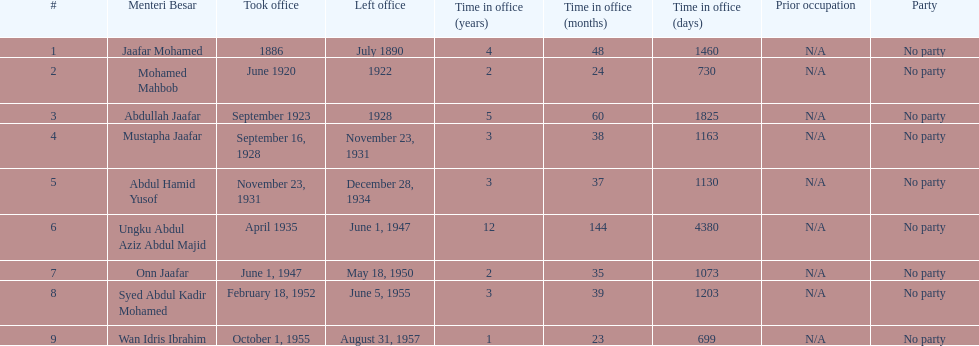Who took office after abdullah jaafar? Mustapha Jaafar. 